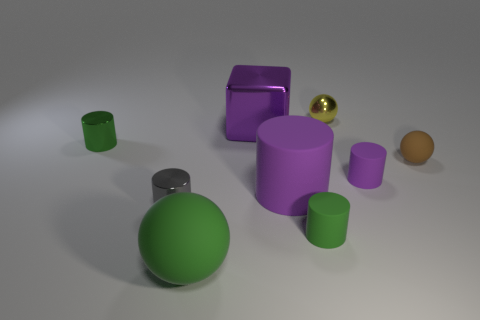The other big matte thing that is the same shape as the brown rubber object is what color?
Your response must be concise. Green. Is there anything else that is the same shape as the brown matte object?
Your answer should be very brief. Yes. Is the number of large green objects behind the purple shiny object greater than the number of cylinders that are in front of the gray cylinder?
Offer a very short reply. No. How big is the green cylinder that is behind the green matte object that is right of the purple thing in front of the tiny purple matte thing?
Your answer should be very brief. Small. Do the yellow sphere and the ball that is to the left of the yellow metallic thing have the same material?
Offer a terse response. No. Is the tiny yellow shiny thing the same shape as the tiny brown rubber object?
Your answer should be very brief. Yes. How many other things are the same material as the tiny yellow ball?
Provide a succinct answer. 3. What number of purple things are the same shape as the tiny yellow metal object?
Provide a succinct answer. 0. The small metal thing that is left of the tiny green matte cylinder and behind the small purple cylinder is what color?
Keep it short and to the point. Green. What number of small brown spheres are there?
Provide a succinct answer. 1. 